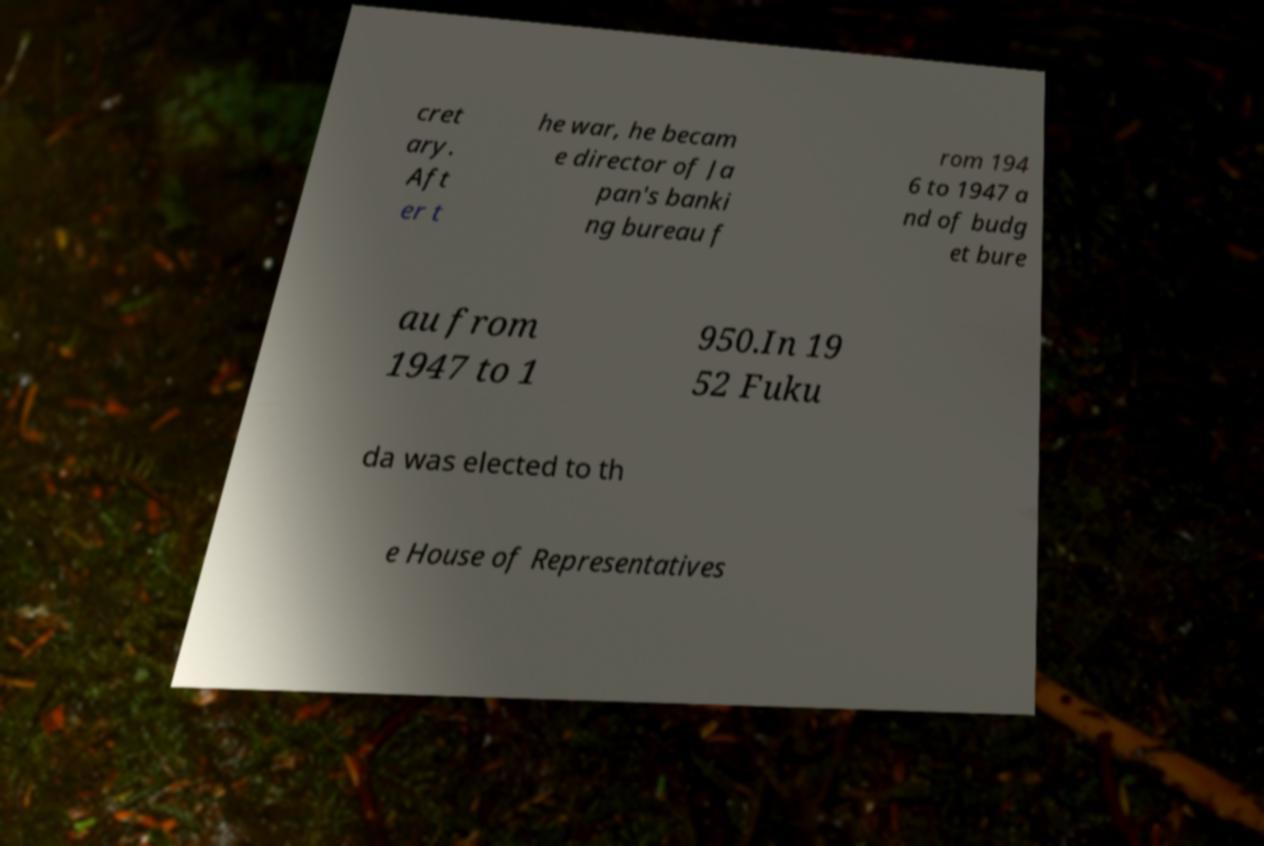What messages or text are displayed in this image? I need them in a readable, typed format. cret ary. Aft er t he war, he becam e director of Ja pan's banki ng bureau f rom 194 6 to 1947 a nd of budg et bure au from 1947 to 1 950.In 19 52 Fuku da was elected to th e House of Representatives 